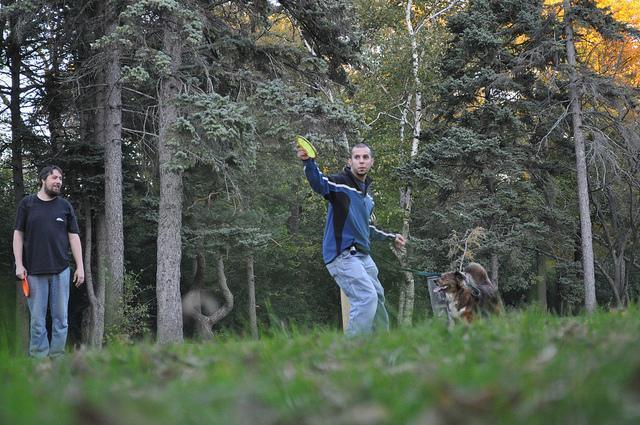How many people are wearing black?
Give a very brief answer. 1. How many people are in the picture?
Give a very brief answer. 2. 